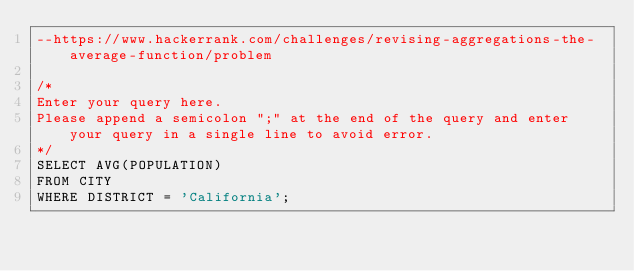<code> <loc_0><loc_0><loc_500><loc_500><_SQL_>--https://www.hackerrank.com/challenges/revising-aggregations-the-average-function/problem

/*
Enter your query here.
Please append a semicolon ";" at the end of the query and enter your query in a single line to avoid error.
*/
SELECT AVG(POPULATION)
FROM CITY
WHERE DISTRICT = 'California';
</code> 